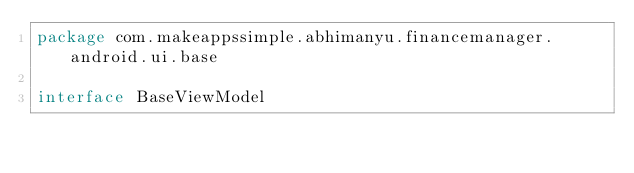Convert code to text. <code><loc_0><loc_0><loc_500><loc_500><_Kotlin_>package com.makeappssimple.abhimanyu.financemanager.android.ui.base

interface BaseViewModel
</code> 